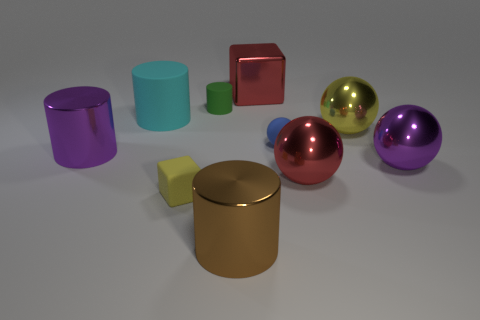Subtract all gray cylinders. Subtract all gray balls. How many cylinders are left? 4 Subtract all cylinders. How many objects are left? 6 Subtract all large blue blocks. Subtract all large red blocks. How many objects are left? 9 Add 4 cyan rubber objects. How many cyan rubber objects are left? 5 Add 2 red shiny cubes. How many red shiny cubes exist? 3 Subtract 1 blue balls. How many objects are left? 9 